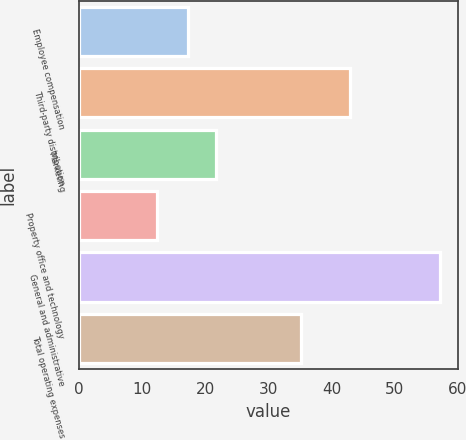Convert chart. <chart><loc_0><loc_0><loc_500><loc_500><bar_chart><fcel>Employee compensation<fcel>Third-party distribution<fcel>Marketing<fcel>Property office and technology<fcel>General and administrative<fcel>Total operating expenses<nl><fcel>17.3<fcel>43<fcel>21.79<fcel>12.3<fcel>57.2<fcel>35.2<nl></chart> 